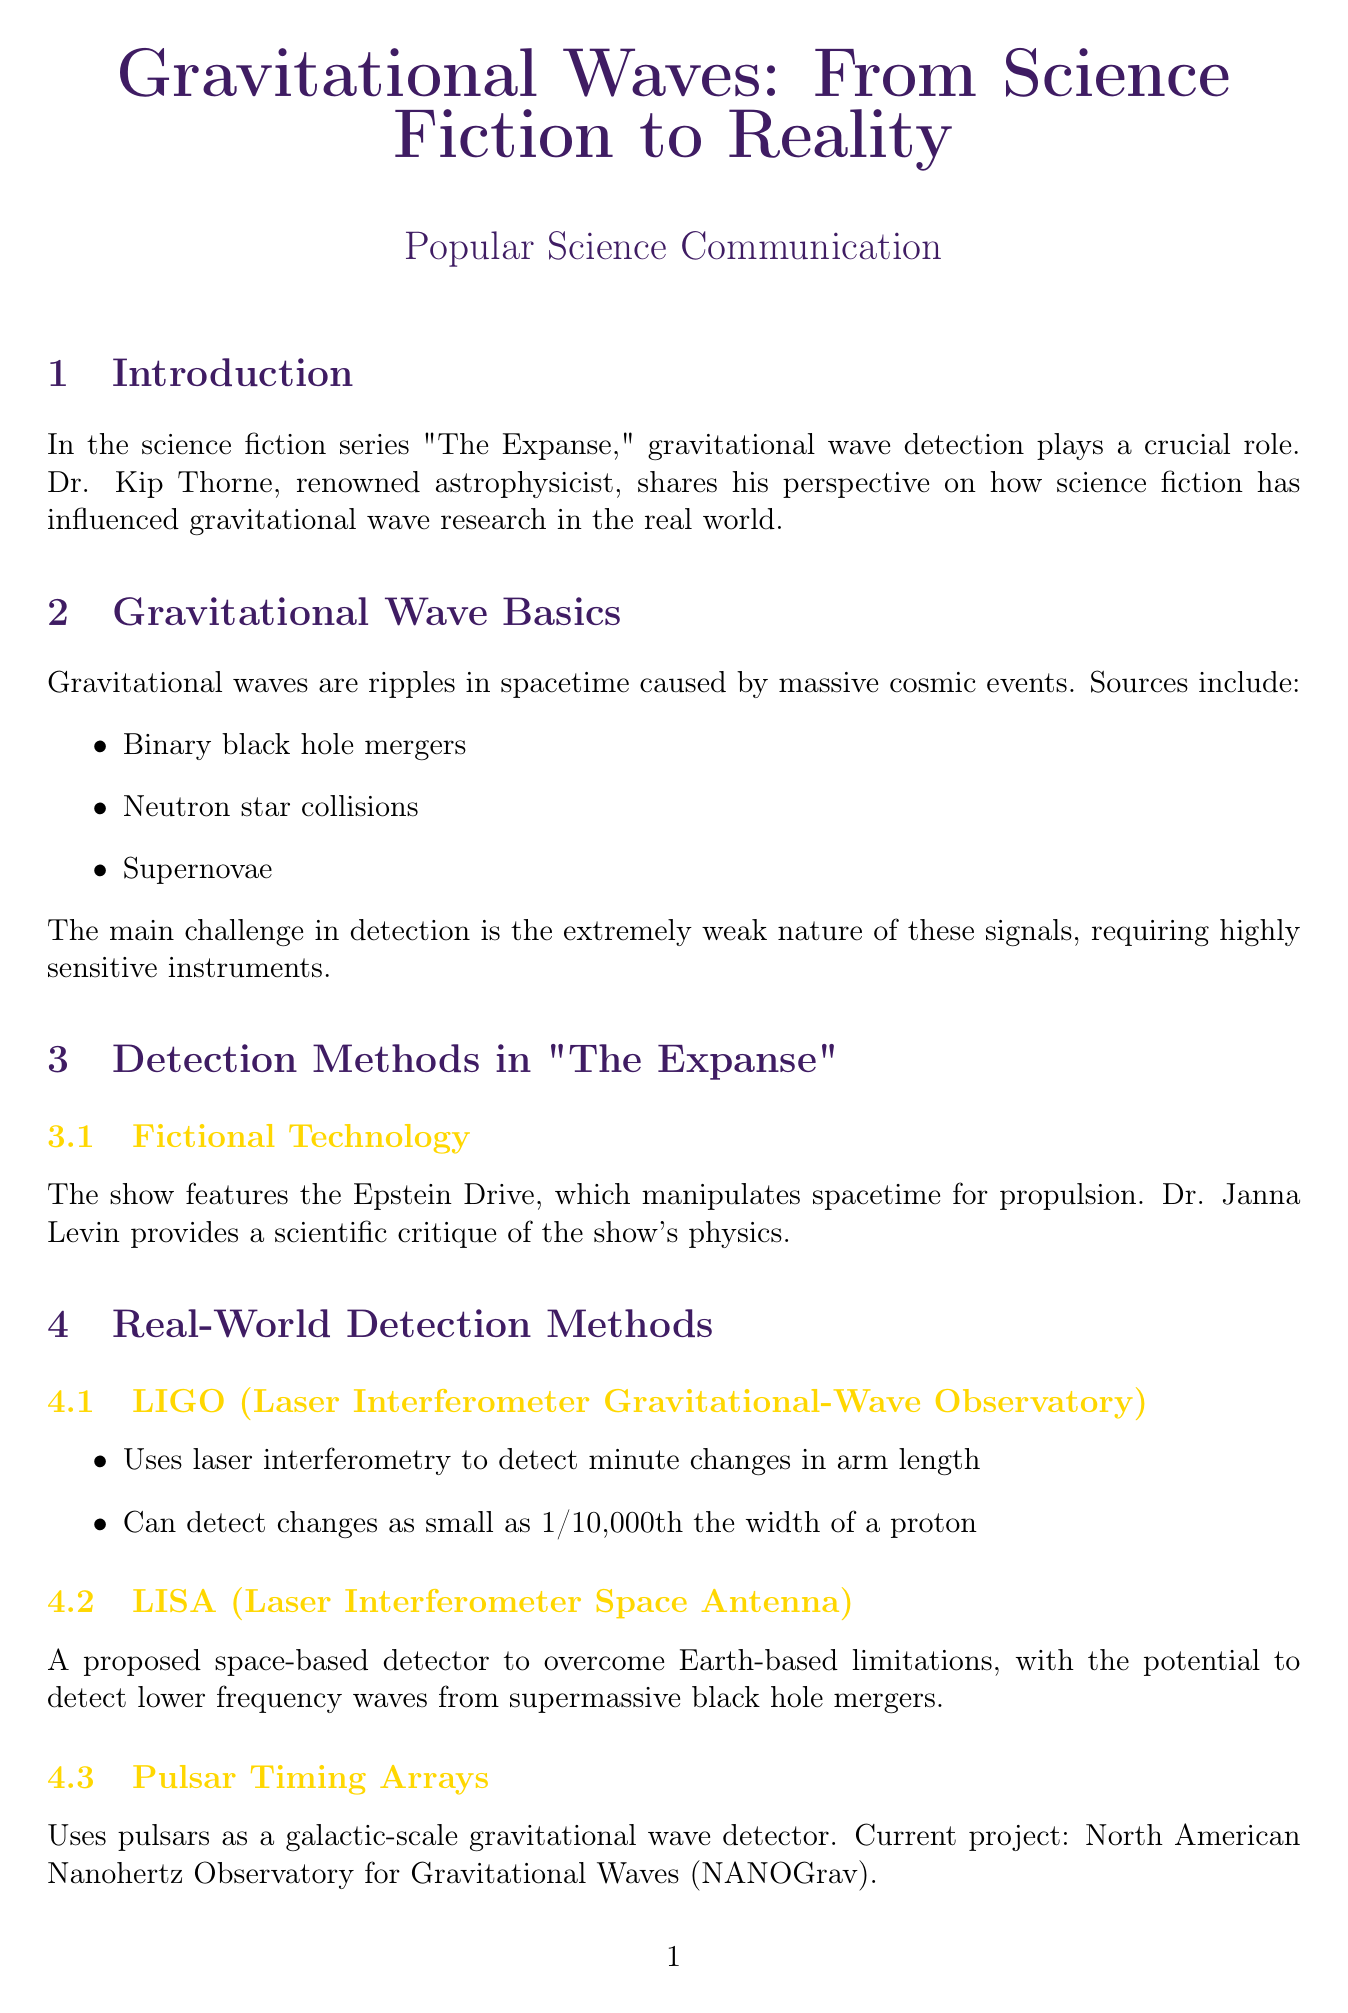How does LIGO detect gravitational waves? LIGO uses laser interferometry to detect minute changes in arm length.
Answer: Laser interferometry What is the significance of GW150914? GW150914 is significant as it was the first direct detection of gravitational waves.
Answer: First direct detection What are two potential future detectors mentioned? The document lists Einstein Telescope and Cosmic Explorer as new detectors.
Answer: Einstein Telescope, Cosmic Explorer What cosmic events are sources of gravitational waves? Sources of gravitational waves include binary black hole mergers, neutron star collisions, and supernovae.
Answer: Binary black hole mergers, neutron star collisions, supernovae What theoretical basis underlies the Epstein Drive from "The Expanse"? The Epstein Drive's theoretical basis is the manipulation of spacetime for propulsion.
Answer: Manipulation of spacetime Which astrophysicist provided a critique of "The Expanse"? Dr. Janna Levin provided a scientific critique of the show's physics.
Answer: Dr. Janna Levin What wave frequency can LISA potentially detect? LISA has the potential to detect lower frequency waves from supermassive black hole mergers.
Answer: Lower frequency waves What technique is mentioned to improve sensitivity in LIGO detectors? Quantum squeezing is mentioned as a technique to reduce quantum noise in LIGO detectors.
Answer: Quantum squeezing What do the first gravitational wave detections usher in? The first gravitational wave detections usher in multi-messenger astronomy.
Answer: Multi-messenger astronomy 